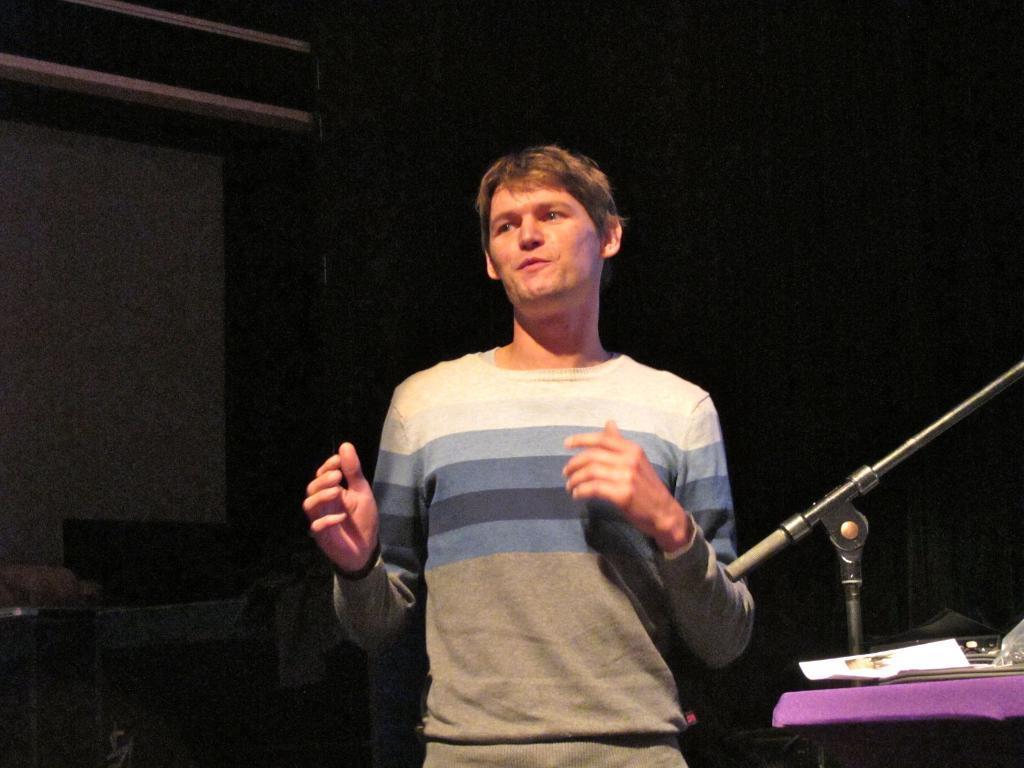How would you summarize this image in a sentence or two? In this picture we can see a man is standing and on the right side of the man it is looking like a table and on the table there is a paper and a stand. Behind the man there is a dark background. 